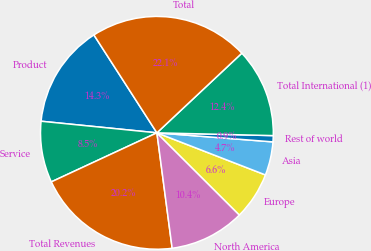Convert chart. <chart><loc_0><loc_0><loc_500><loc_500><pie_chart><fcel>Product<fcel>Service<fcel>Total Revenues<fcel>North America<fcel>Europe<fcel>Asia<fcel>Rest of world<fcel>Total International (1)<fcel>Total<nl><fcel>14.31%<fcel>8.51%<fcel>20.17%<fcel>10.44%<fcel>6.58%<fcel>4.65%<fcel>0.86%<fcel>12.37%<fcel>22.11%<nl></chart> 